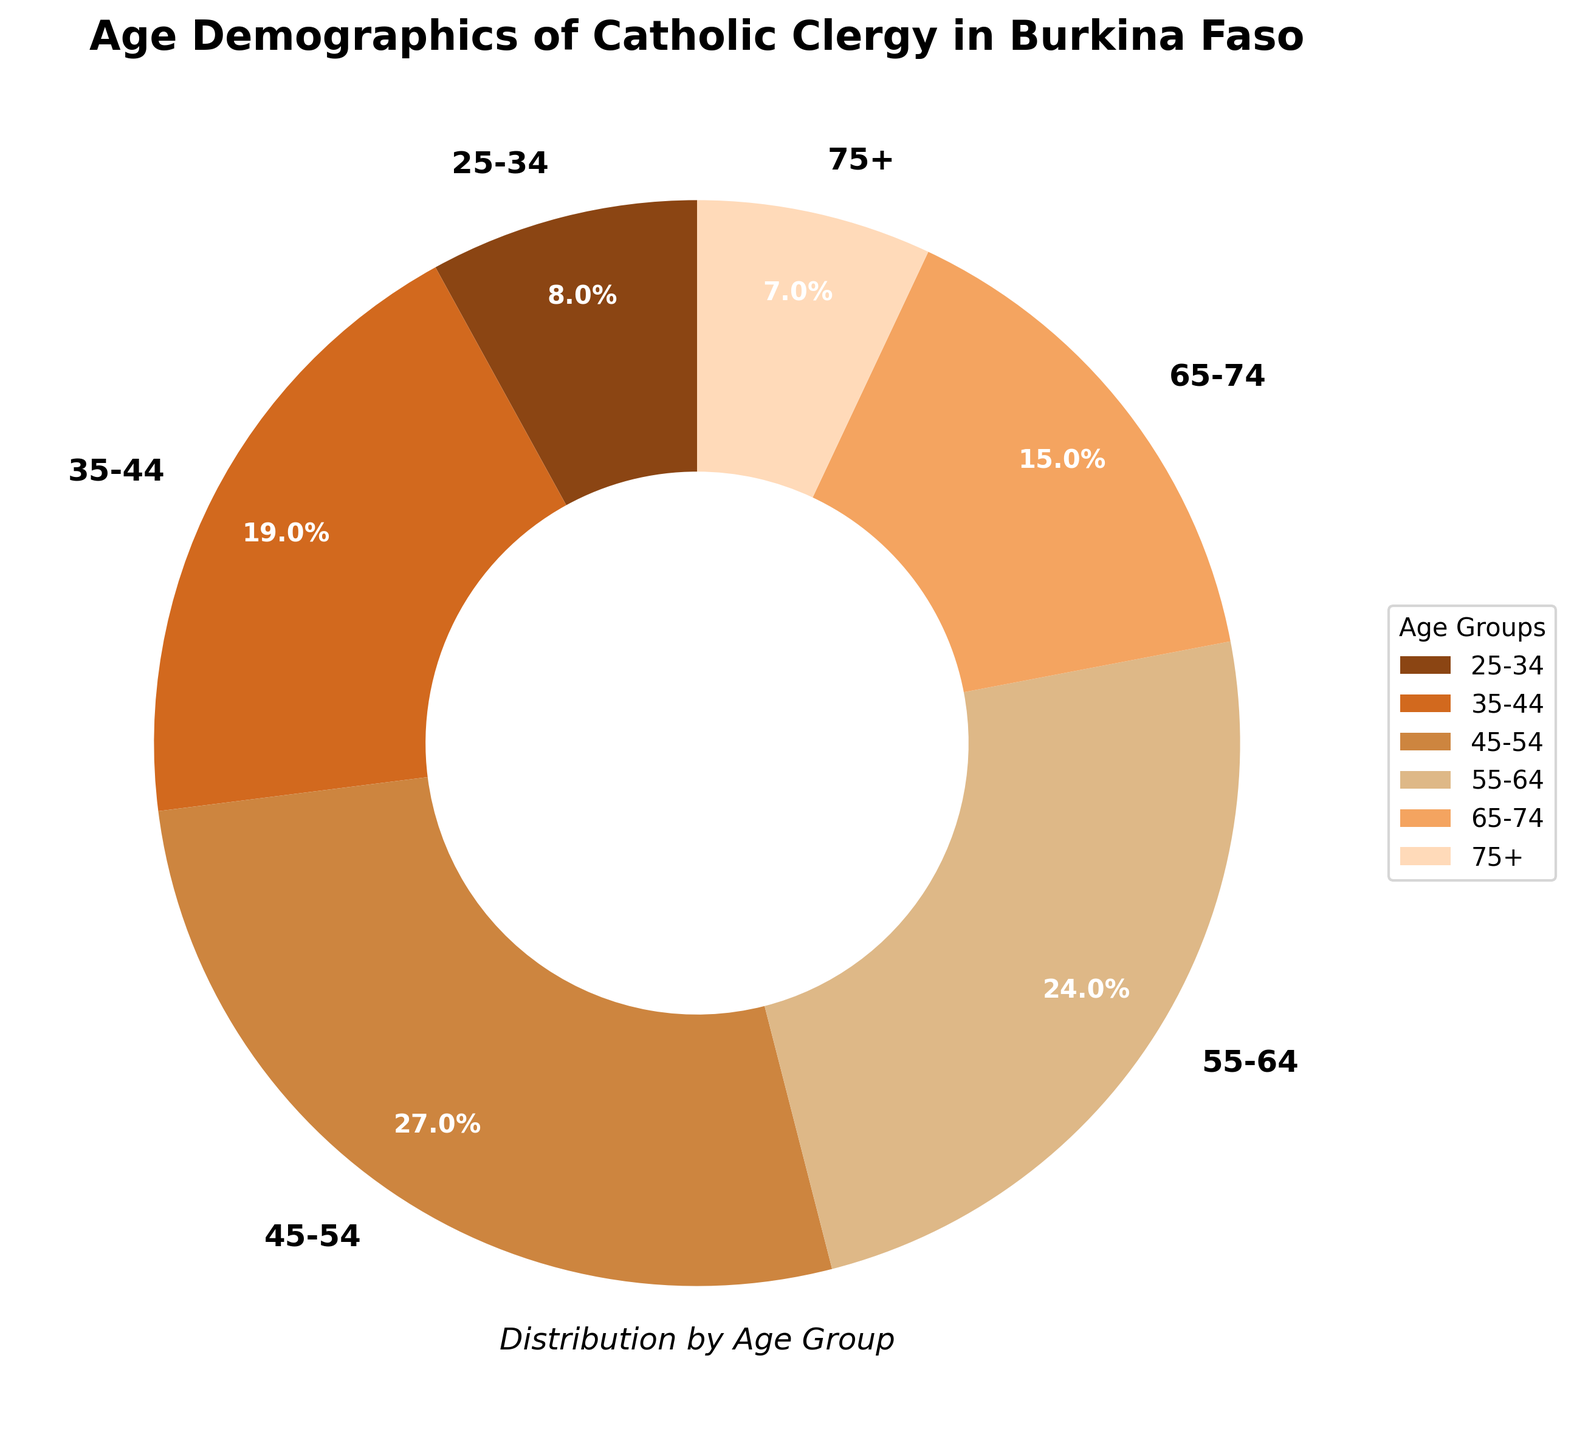What is the largest age group among the Catholic clergy in Burkina Faso? To determine the largest age group, look at the percentages represented in the pie chart. The 45-54 age group has the highest percentage at 27%.
Answer: 45-54 What is the difference in percentage between the 25-34 age group and the 75+ age group? The 25-34 age group has 8% and the 75+ age group has 7%. Subtract 7% from 8% to find the difference, which is 1%.
Answer: 1% Which two age groups together make up almost half of the Catholic clergy in Burkina Faso? The 45-54 and 55-64 age groups have 27% and 24% respectively. Adding these gives 27% + 24% = 51%, which is just over half.
Answer: 45-54 and 55-64 How does the proportion of clergy aged 55-64 compare to those aged 35-44? The 55-64 age group has 24%, while the 35-44 age group has 19%. Thus, the 55-64 category is 5% higher.
Answer: 5% higher What percentage of clergy are 65 years old or older? Combine the percentages for the 65-74 and 75+ age groups. 15% + 7% = 22%.
Answer: 22% What is the sum of the percentages for the middle three age groups (35-44, 45-54, 55-64)? Sum the percentages for these groups: 19% + 27% + 24% = 70%.
Answer: 70% What age group is represented by the smallest wedge in the pie chart? The smallest wedge represents the 75+ age group, which has 7%.
Answer: 75+ How does the proportion of clergy aged 55-64 compare to those aged 65-74? The 55-64 age group has 24%, while the 65-74 age group has 15%. Thus, the 55-64 category is 9% higher.
Answer: 9% higher What visual attribute can you use to easily identify the age group with the highest percentage? The wedge with the highest percentage occupies the largest area in the pie chart. The wedge for the 45-54 age group appears largest.
Answer: largest wedge What is the average percentage of the clergy in all age groups below 45 years old? Sum the percentages for the 25-34 (8%) and 35-44 (19%) groups and divide by 2. The average is (8% + 19%) / 2 = 13.5%.
Answer: 13.5% 